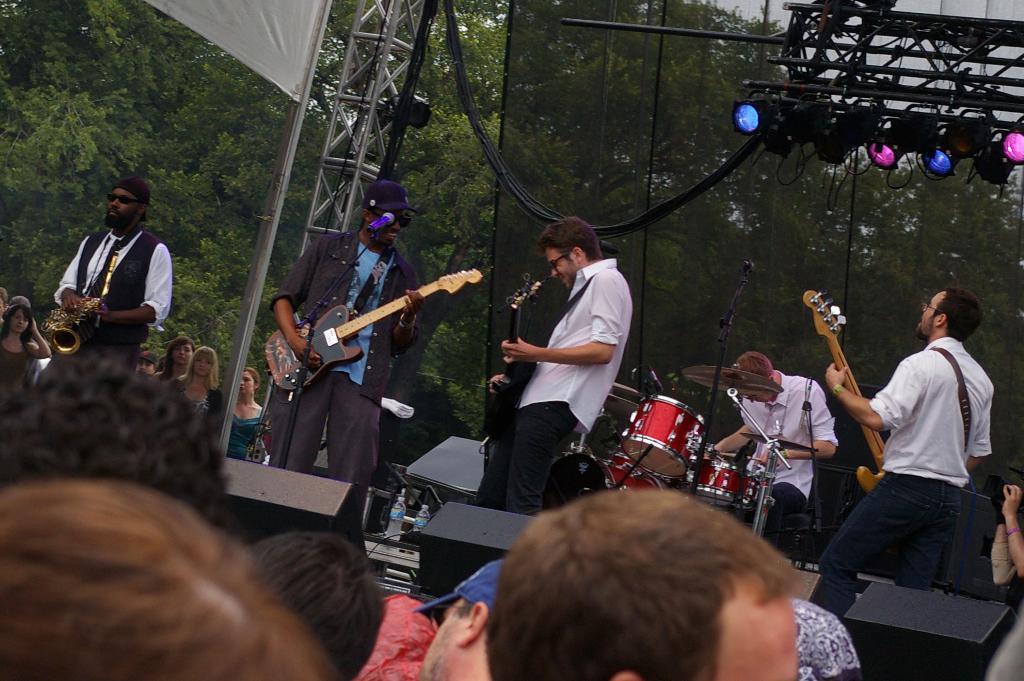In one or two sentences, can you explain what this image depicts? In this image i can see group of people playing musical instruments, the man standing at front wearing two shirts white in color, and two black jackets at left,in front there are few other members standing, at the back ground i can see few lights, railing, a tree, a man standing at front wearing a cap. 